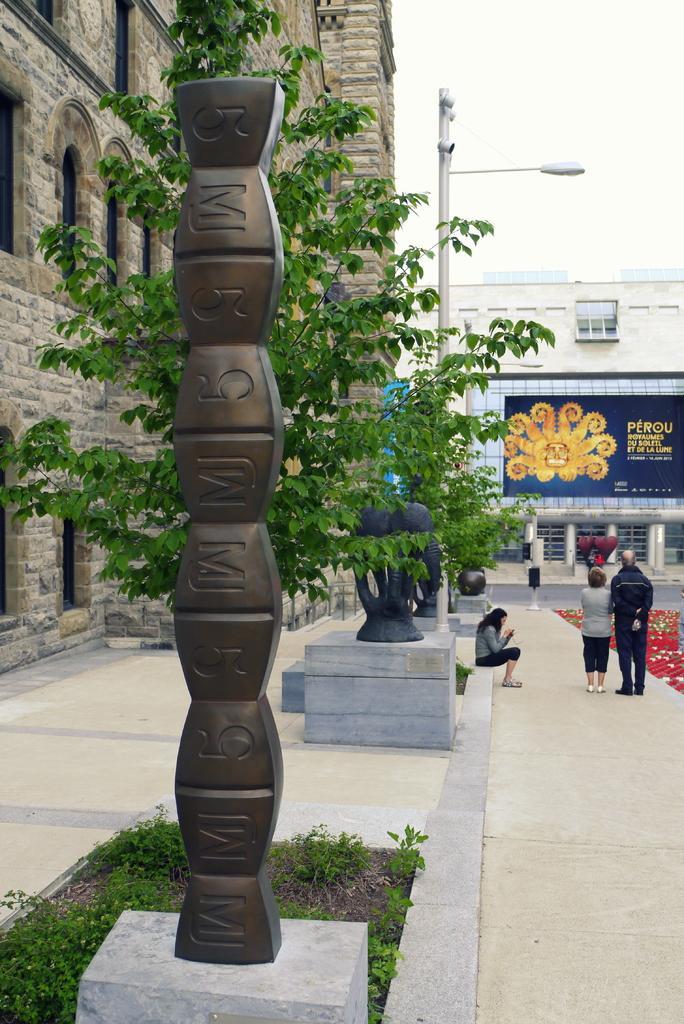Describe this image in one or two sentences. In this picture we can see group of people, a woman is seated and two are standing, beside to them we can find few trees, pole, buildings and a light, in the background we can see a hoarding. 